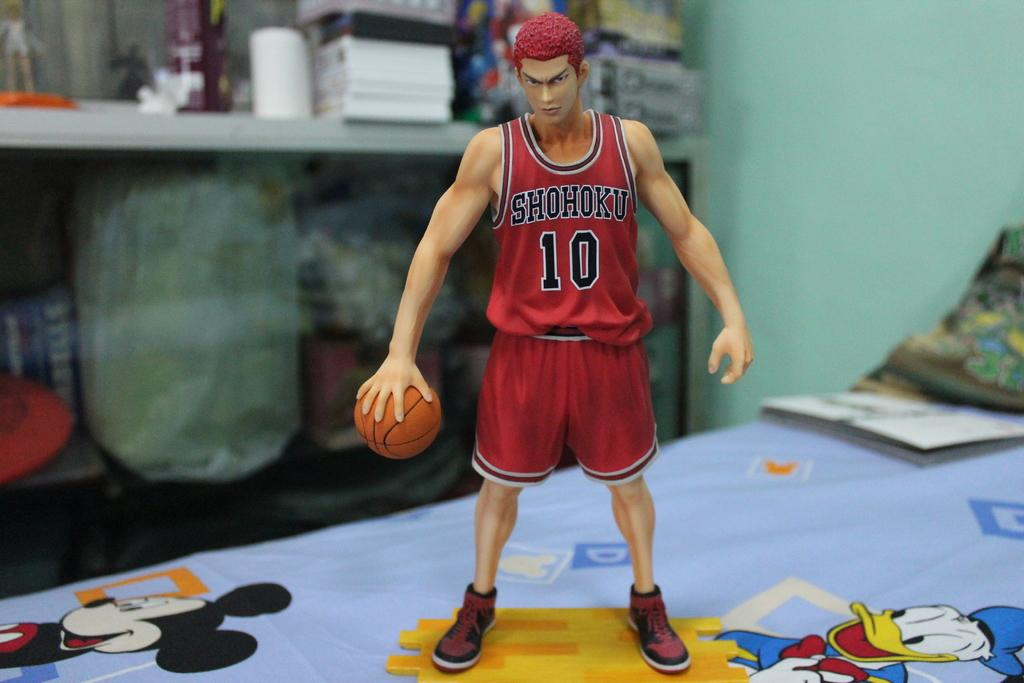What object can be seen in the image? There is a toy in the image. What is the toy holding? The toy is holding a basketball. Can you describe the background of the image? The background of the image is blurry. What type of pail is being used to celebrate the birthday in the image? There is no pail or birthday celebration present in the image. How does the alarm sound in the image? There is no alarm present in the image. 